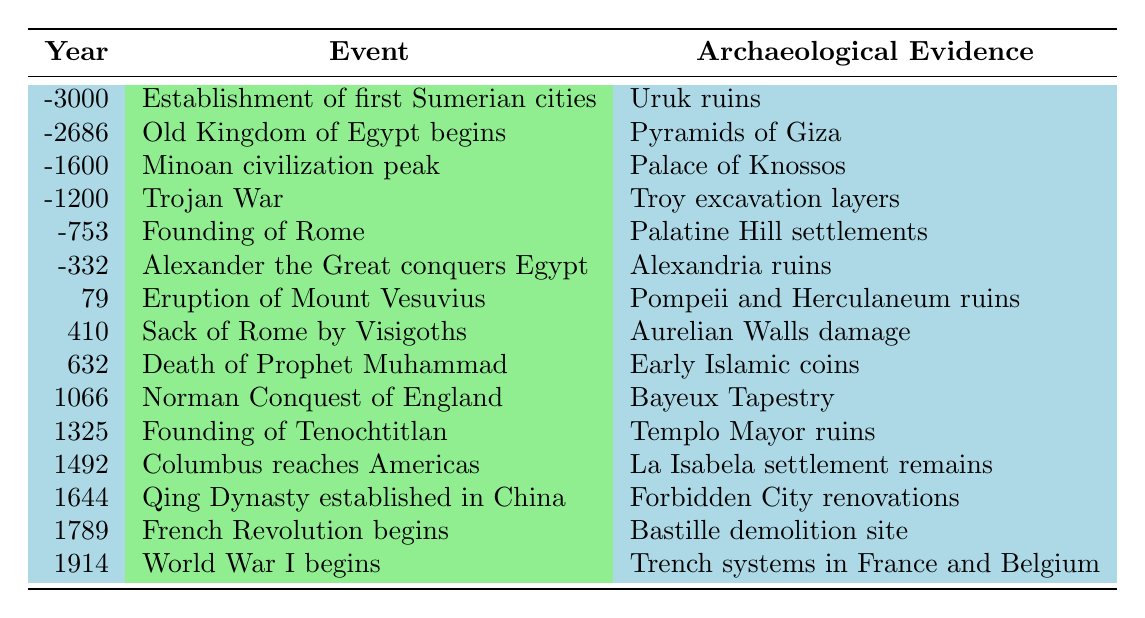What is the archaeological evidence for the founding of Tenochtitlan? The table indicates that the archaeological evidence for the founding of Tenochtitlan in the year 1325 is the Templo Mayor ruins.
Answer: Templo Mayor ruins Which event occurred first, the establishment of the first Sumerian cities or the founding of Rome? According to the table, the establishment of the first Sumerian cities occurred in the year -3000, while the founding of Rome occurred in -753. Since -3000 is earlier than -753, the Sumerian cities were established first.
Answer: Establishment of first Sumerian cities Was the French Revolution before or after World War I? The table shows that the French Revolution began in 1789 and World War I began in 1914. Since 1789 is earlier than 1914, the French Revolution occurred before World War I.
Answer: Before How many events are listed from the year 1000 onwards? Looking at the table, the events listed from the year 1000 onwards are the Norman Conquest of England (1066), the founding of Tenochtitlan (1325), Columbus reaching the Americas (1492), the establishment of the Qing Dynasty in China (1644), the beginning of the French Revolution (1789), and the beginning of World War I (1914). This totals six events.
Answer: 6 What is the first event that has archaeological evidence related to a dynasty? According to the table, the first instance of a dynasty-related event is the establishment of the Old Kingdom of Egypt in -2686, with the archaeological evidence being the Pyramids of Giza.
Answer: Old Kingdom of Egypt begins List the events that occurred in the 1st millennium. The events in the 1st millennium listed in the table are the eruption of Mount Vesuvius (79), the sack of Rome by the Visigoths (410), and the death of Prophet Muhammad (632). Thus, there are three events in total.
Answer: 3 What archaeological evidence is associated with the event of Alexander the Great conquering Egypt? The table states that the archaeological evidence related to Alexander the Great conquering Egypt in -332 is the Alexandria ruins.
Answer: Alexandria ruins Which event has the most recent archaeological evidence? World War I in 1914 is the most recent event with archaeological evidence according to the table. The evidence listed is the trench systems in France and Belgium.
Answer: World War I begins What evidence is linked to the eruption of Mount Vesuvius? The archaeological evidence linked to the eruption of Mount Vesuvius in the year 79 is the ruins of Pompeii and Herculaneum.
Answer: Pompeii and Herculaneum ruins Is the Bayeux Tapestry associated with an event that took place in the 11th century? The table presents that the Norman Conquest of England occurred in 1066, which is in the 11th century, and has the Bayeux Tapestry as its archaeological evidence. Therefore, this statement is true.
Answer: Yes 